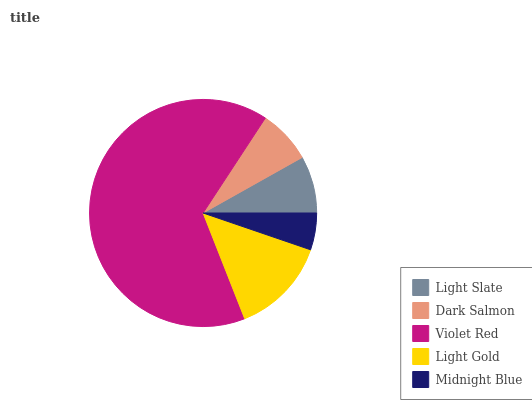Is Midnight Blue the minimum?
Answer yes or no. Yes. Is Violet Red the maximum?
Answer yes or no. Yes. Is Dark Salmon the minimum?
Answer yes or no. No. Is Dark Salmon the maximum?
Answer yes or no. No. Is Light Slate greater than Dark Salmon?
Answer yes or no. Yes. Is Dark Salmon less than Light Slate?
Answer yes or no. Yes. Is Dark Salmon greater than Light Slate?
Answer yes or no. No. Is Light Slate less than Dark Salmon?
Answer yes or no. No. Is Light Slate the high median?
Answer yes or no. Yes. Is Light Slate the low median?
Answer yes or no. Yes. Is Light Gold the high median?
Answer yes or no. No. Is Midnight Blue the low median?
Answer yes or no. No. 